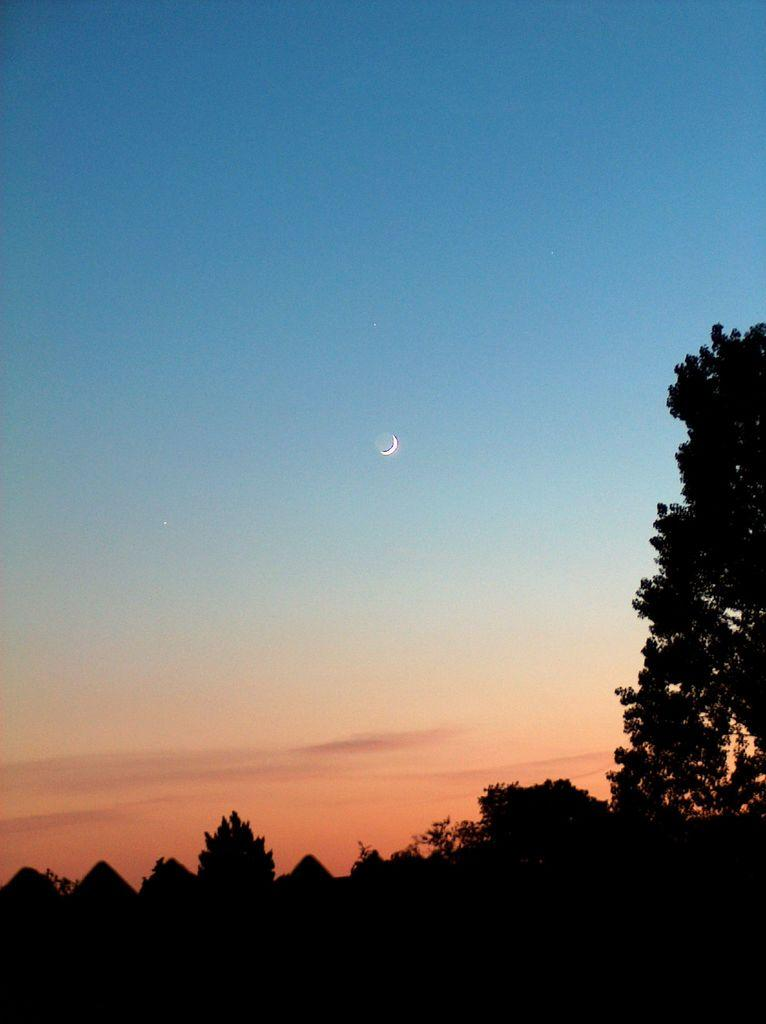What type of vegetation can be seen in the image? There are trees in the image. What is visible in the background of the image? The sky is visible in the background of the image. What can be observed in the sky? Clouds are present in the sky. What type of support can be seen in the image? There is no support visible in the image. 